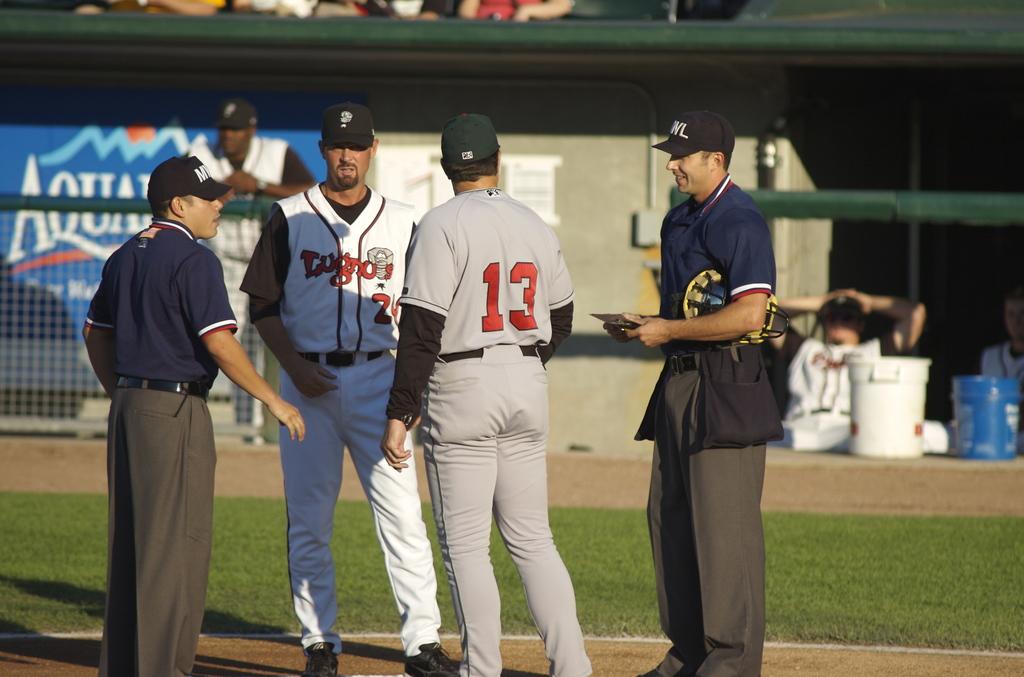What number is in red on the back of a shirt?
Ensure brevity in your answer.  13. What is the name of the team?
Offer a terse response. Lugnuts. 